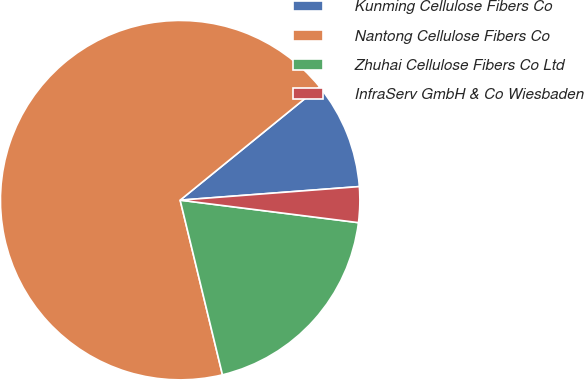Convert chart. <chart><loc_0><loc_0><loc_500><loc_500><pie_chart><fcel>Kunming Cellulose Fibers Co<fcel>Nantong Cellulose Fibers Co<fcel>Zhuhai Cellulose Fibers Co Ltd<fcel>InfraServ GmbH & Co Wiesbaden<nl><fcel>9.67%<fcel>67.91%<fcel>19.22%<fcel>3.2%<nl></chart> 